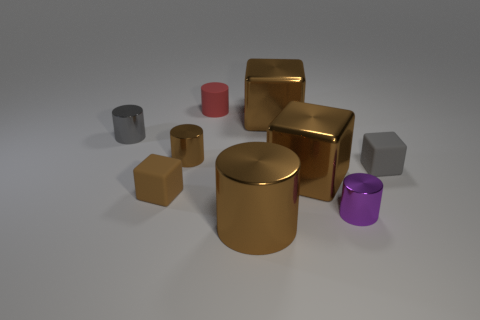Can you tell me what the largest object in the image is? The largest object in the image appears to be the gold cylinder at the center. 